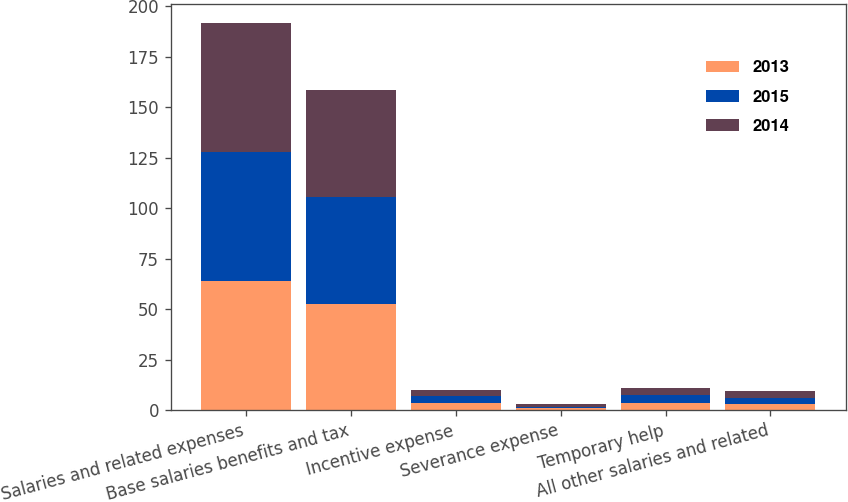Convert chart to OTSL. <chart><loc_0><loc_0><loc_500><loc_500><stacked_bar_chart><ecel><fcel>Salaries and related expenses<fcel>Base salaries benefits and tax<fcel>Incentive expense<fcel>Severance expense<fcel>Temporary help<fcel>All other salaries and related<nl><fcel>2013<fcel>63.8<fcel>52.7<fcel>3.7<fcel>0.9<fcel>3.6<fcel>2.9<nl><fcel>2015<fcel>64<fcel>52.6<fcel>3.5<fcel>0.9<fcel>3.8<fcel>3.2<nl><fcel>2014<fcel>63.8<fcel>52.9<fcel>3<fcel>1.1<fcel>3.6<fcel>3.2<nl></chart> 